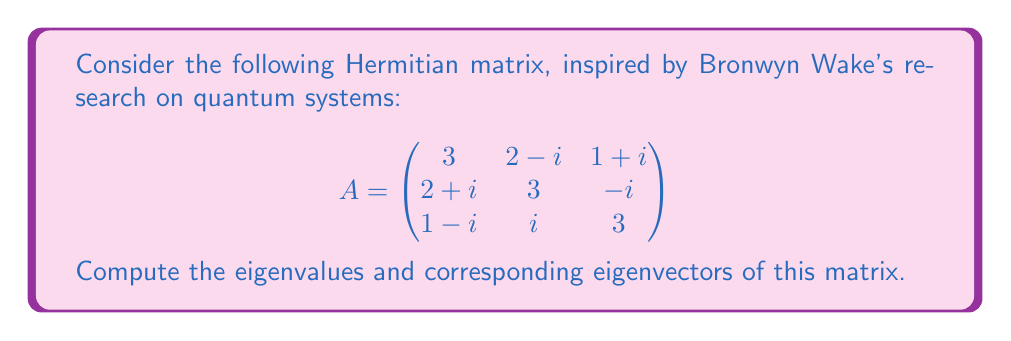Can you answer this question? To find the eigenvalues and eigenvectors of the given Hermitian matrix A, we'll follow these steps:

1) First, we need to find the characteristic equation:
   $$det(A - \lambda I) = 0$$

2) Expanding the determinant:
   $$\begin{vmatrix}
   3-\lambda & 2-i & 1+i \\
   2+i & 3-\lambda & -i \\
   1-i & i & 3-\lambda
   \end{vmatrix} = 0$$

3) Calculating the determinant:
   $$(3-\lambda)^3 + (2-i)(1-i)(-i) + (1+i)(2+i)i - (3-\lambda)(2-i)(2+i) - (3-\lambda)(1+i)(1-i) - (1-i)(-i)i = 0$$

4) Simplifying:
   $$-\lambda^3 + 9\lambda^2 - 24\lambda + 16 = 0$$

5) This cubic equation can be factored as:
   $$-(\lambda - 1)(\lambda - 4)(\lambda - 4) = 0$$

6) Therefore, the eigenvalues are:
   $$\lambda_1 = 1, \lambda_2 = \lambda_3 = 4$$

7) For each eigenvalue, we need to solve $(A - \lambda I)v = 0$ to find the corresponding eigenvectors:

   For $\lambda_1 = 1$:
   $$\begin{pmatrix}
   2 & 2-i & 1+i \\
   2+i & 2 & -i \\
   1-i & i & 2
   \end{pmatrix}\begin{pmatrix}
   v_1 \\ v_2 \\ v_3
   \end{pmatrix} = \begin{pmatrix}
   0 \\ 0 \\ 0
   \end{pmatrix}$$

   Solving this system gives us: $v_1 = 1, v_2 = -1-i, v_3 = -1+i$

   For $\lambda_2 = \lambda_3 = 4$:
   $$\begin{pmatrix}
   -1 & 2-i & 1+i \\
   2+i & -1 & -i \\
   1-i & i & -1
   \end{pmatrix}\begin{pmatrix}
   v_1 \\ v_2 \\ v_3
   \end{pmatrix} = \begin{pmatrix}
   0 \\ 0 \\ 0
   \end{pmatrix}$$

   Solving this system gives us two linearly independent solutions:
   $v_1 = 1, v_2 = i, v_3 = -1$ and $v_1 = 1, v_2 = -1, v_3 = i$

8) Normalizing these eigenvectors:

   $v_1 = \frac{1}{\sqrt{5}}(1, -1-i, -1+i)$
   $v_2 = \frac{1}{\sqrt{3}}(1, i, -1)$
   $v_3 = \frac{1}{\sqrt{3}}(1, -1, i)$
Answer: Eigenvalues: $\lambda_1 = 1, \lambda_2 = \lambda_3 = 4$
Eigenvectors: $v_1 = \frac{1}{\sqrt{5}}(1, -1-i, -1+i)$, $v_2 = \frac{1}{\sqrt{3}}(1, i, -1)$, $v_3 = \frac{1}{\sqrt{3}}(1, -1, i)$ 